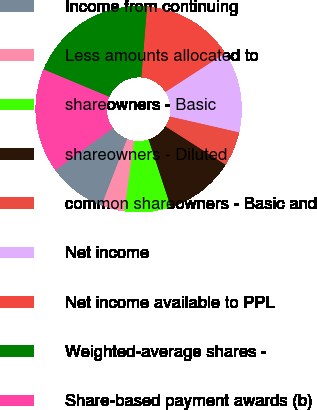Convert chart to OTSL. <chart><loc_0><loc_0><loc_500><loc_500><pie_chart><fcel>Income from continuing<fcel>Less amounts allocated to<fcel>shareowners - Basic<fcel>shareowners - Diluted<fcel>common shareowners - Basic and<fcel>Net income<fcel>Net income available to PPL<fcel>Weighted-average shares -<fcel>Share-based payment awards (b)<nl><fcel>9.09%<fcel>3.64%<fcel>7.27%<fcel>10.91%<fcel>5.45%<fcel>12.73%<fcel>14.55%<fcel>20.0%<fcel>16.36%<nl></chart> 